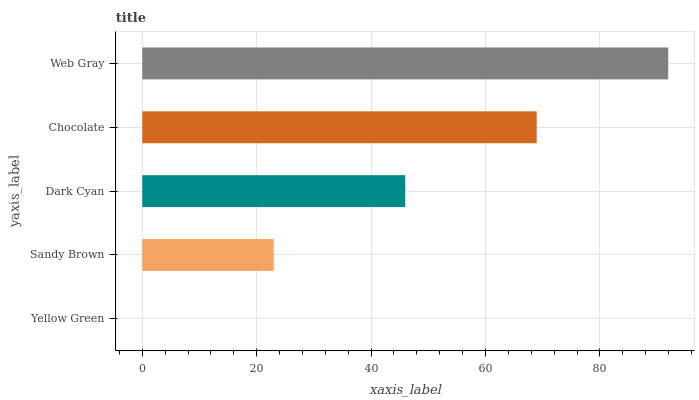Is Yellow Green the minimum?
Answer yes or no. Yes. Is Web Gray the maximum?
Answer yes or no. Yes. Is Sandy Brown the minimum?
Answer yes or no. No. Is Sandy Brown the maximum?
Answer yes or no. No. Is Sandy Brown greater than Yellow Green?
Answer yes or no. Yes. Is Yellow Green less than Sandy Brown?
Answer yes or no. Yes. Is Yellow Green greater than Sandy Brown?
Answer yes or no. No. Is Sandy Brown less than Yellow Green?
Answer yes or no. No. Is Dark Cyan the high median?
Answer yes or no. Yes. Is Dark Cyan the low median?
Answer yes or no. Yes. Is Chocolate the high median?
Answer yes or no. No. Is Yellow Green the low median?
Answer yes or no. No. 